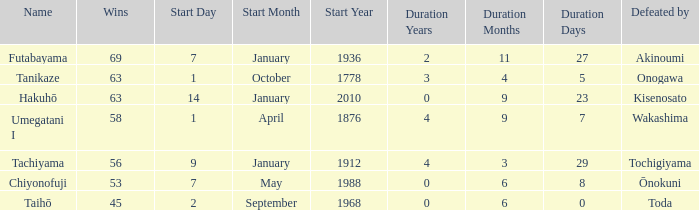How many successful matches took place before being beaten by toda? 1.0. 